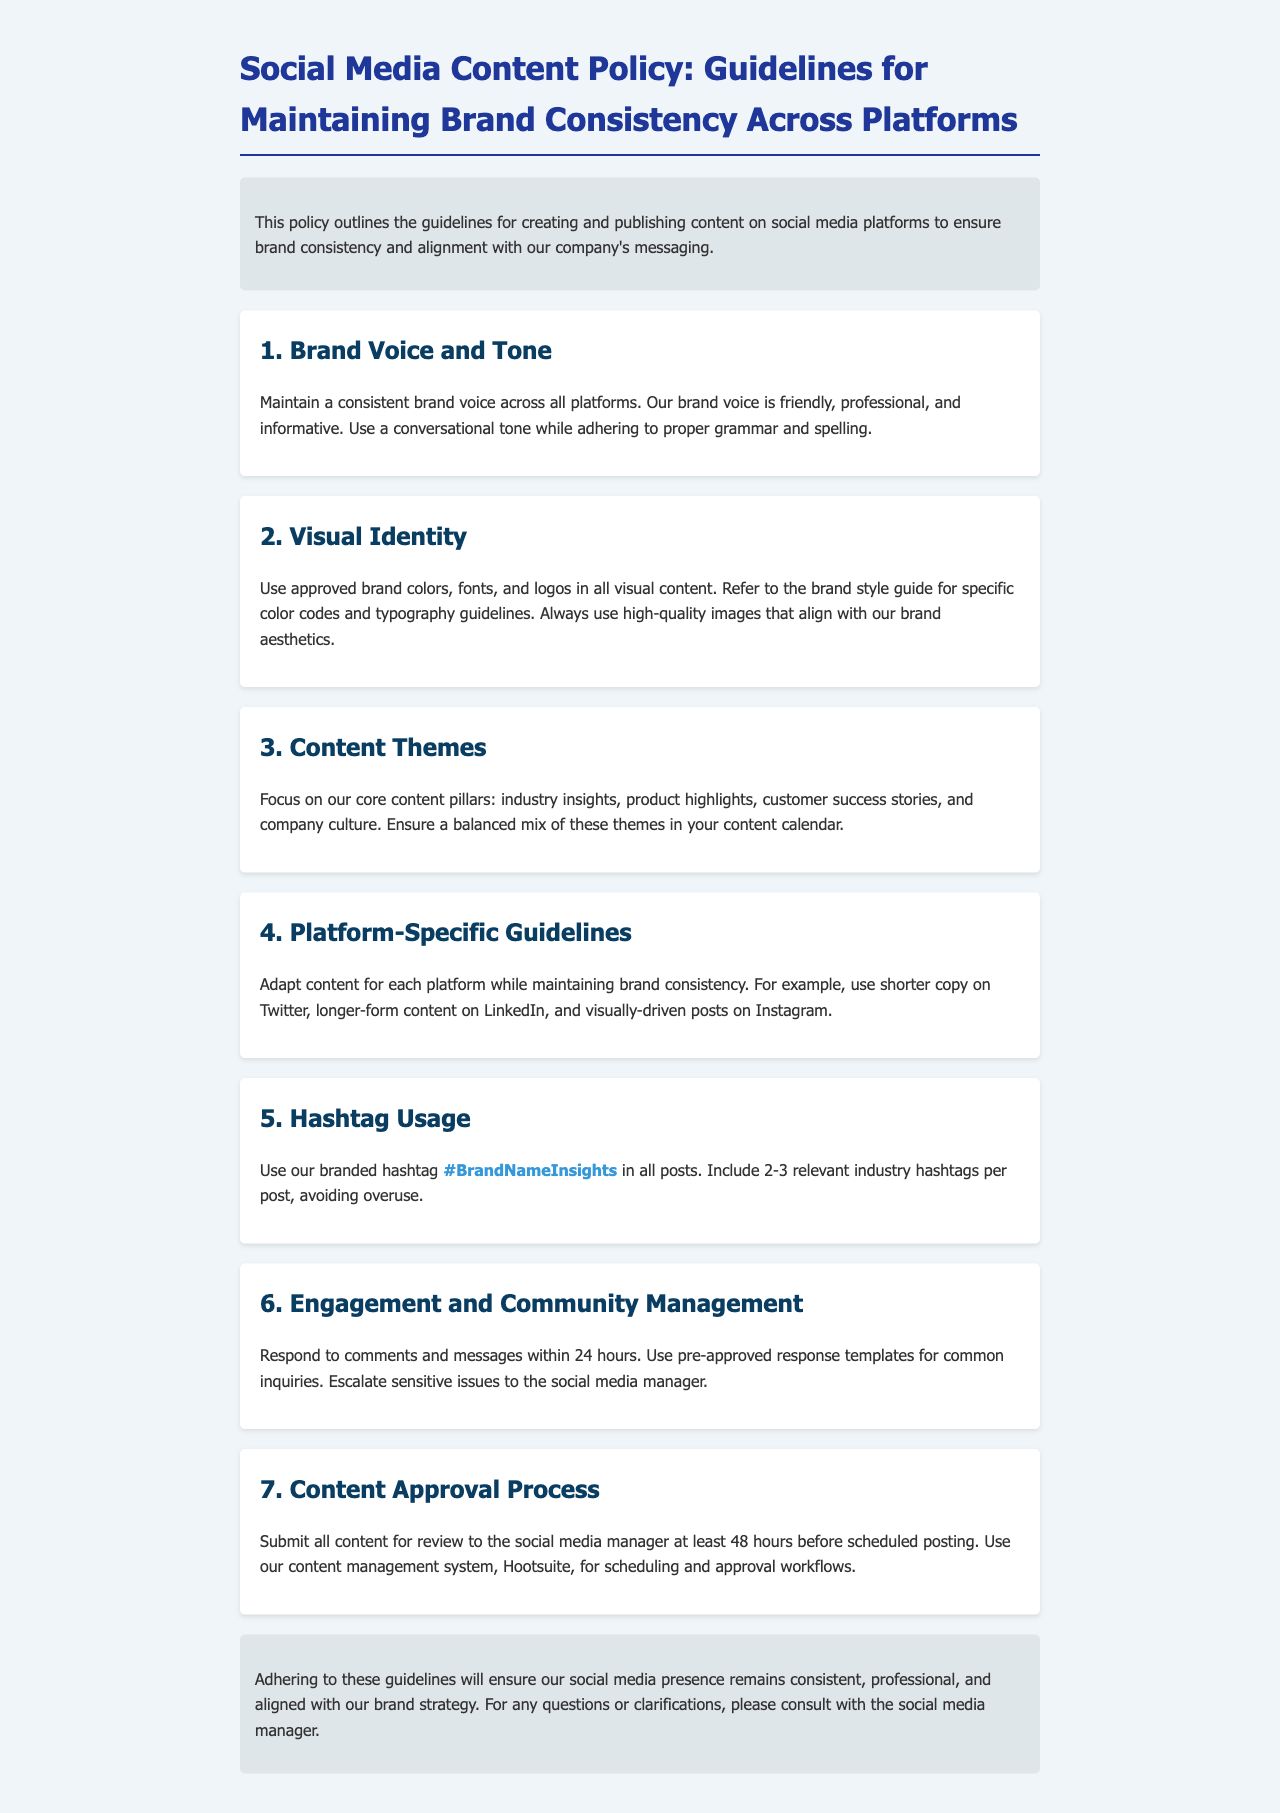What is the brand voice? The brand voice is characterized as friendly, professional, and informative.
Answer: friendly, professional, and informative How many core content pillars are mentioned? The document states there are four core content pillars to focus on.
Answer: 4 What is the approved branded hashtag? The approved branded hashtag used in all posts is specified in the document.
Answer: #BrandNameInsights What is the time frame for responding to comments and messages? The guideline indicates a specific time frame for engagement with the audience.
Answer: 24 hours How many hours before posting should content be submitted for review? The document outlines the number of hours content should be submitted prior to scheduled posting.
Answer: 48 hours What platform-specific guideline is mentioned for Twitter? The document advises using a specific approach for creating content on Twitter.
Answer: shorter copy What is the content management system mentioned for scheduling? The social media content policy specifies a content management system for scheduling purposes.
Answer: Hootsuite What is the primary purpose of this policy document? The document outlines its main objective regarding social media content creation and publication.
Answer: brand consistency and alignment with our company's messaging 